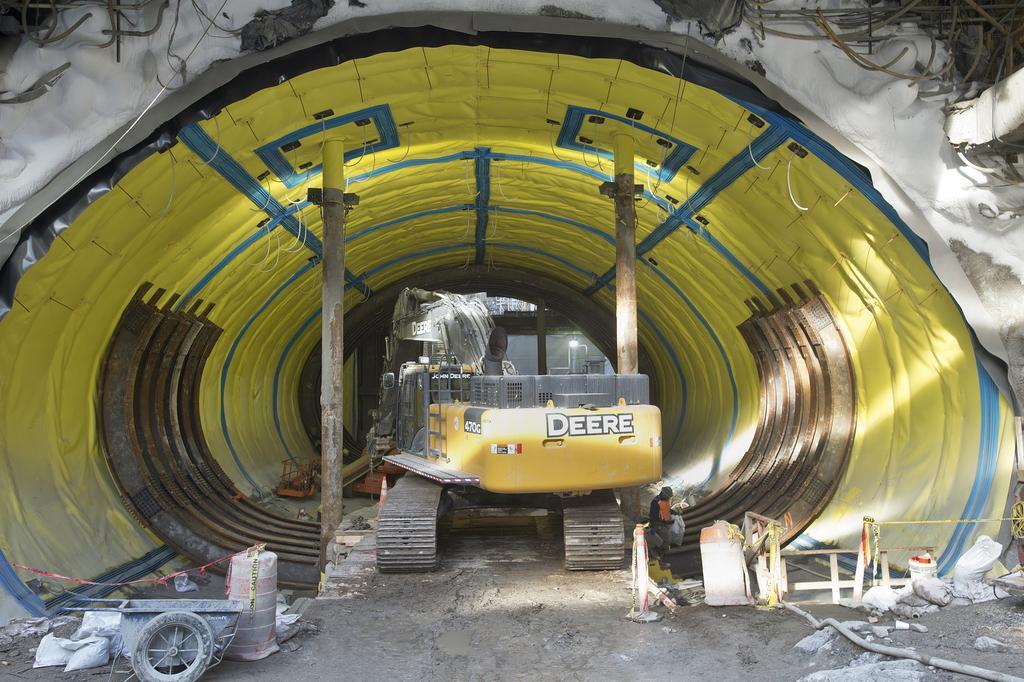How would you summarize this image in a sentence or two? There is a construction of something going on. There are pillars. Also there is a excavator. Near to that there is a person. Also there are some other items on the ground. 